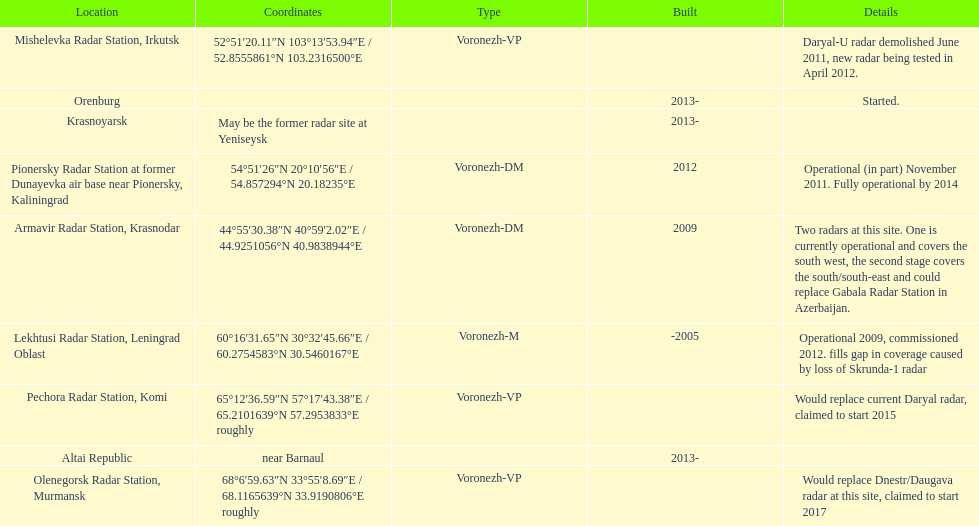Would you mind parsing the complete table? {'header': ['Location', 'Coordinates', 'Type', 'Built', 'Details'], 'rows': [['Mishelevka Radar Station, Irkutsk', '52°51′20.11″N 103°13′53.94″E\ufeff / \ufeff52.8555861°N 103.2316500°E', 'Voronezh-VP', '', 'Daryal-U radar demolished June 2011, new radar being tested in April 2012.'], ['Orenburg', '', '', '2013-', 'Started.'], ['Krasnoyarsk', 'May be the former radar site at Yeniseysk', '', '2013-', ''], ['Pionersky Radar Station at former Dunayevka air base near Pionersky, Kaliningrad', '54°51′26″N 20°10′56″E\ufeff / \ufeff54.857294°N 20.18235°E', 'Voronezh-DM', '2012', 'Operational (in part) November 2011. Fully operational by 2014'], ['Armavir Radar Station, Krasnodar', '44°55′30.38″N 40°59′2.02″E\ufeff / \ufeff44.9251056°N 40.9838944°E', 'Voronezh-DM', '2009', 'Two radars at this site. One is currently operational and covers the south west, the second stage covers the south/south-east and could replace Gabala Radar Station in Azerbaijan.'], ['Lekhtusi Radar Station, Leningrad Oblast', '60°16′31.65″N 30°32′45.66″E\ufeff / \ufeff60.2754583°N 30.5460167°E', 'Voronezh-M', '-2005', 'Operational 2009, commissioned 2012. fills gap in coverage caused by loss of Skrunda-1 radar'], ['Pechora Radar Station, Komi', '65°12′36.59″N 57°17′43.38″E\ufeff / \ufeff65.2101639°N 57.2953833°E roughly', 'Voronezh-VP', '', 'Would replace current Daryal radar, claimed to start 2015'], ['Altai Republic', 'near Barnaul', '', '2013-', ''], ['Olenegorsk Radar Station, Murmansk', '68°6′59.63″N 33°55′8.69″E\ufeff / \ufeff68.1165639°N 33.9190806°E roughly', 'Voronezh-VP', '', 'Would replace Dnestr/Daugava radar at this site, claimed to start 2017']]} How many voronezh radars were built before 2010? 2. 